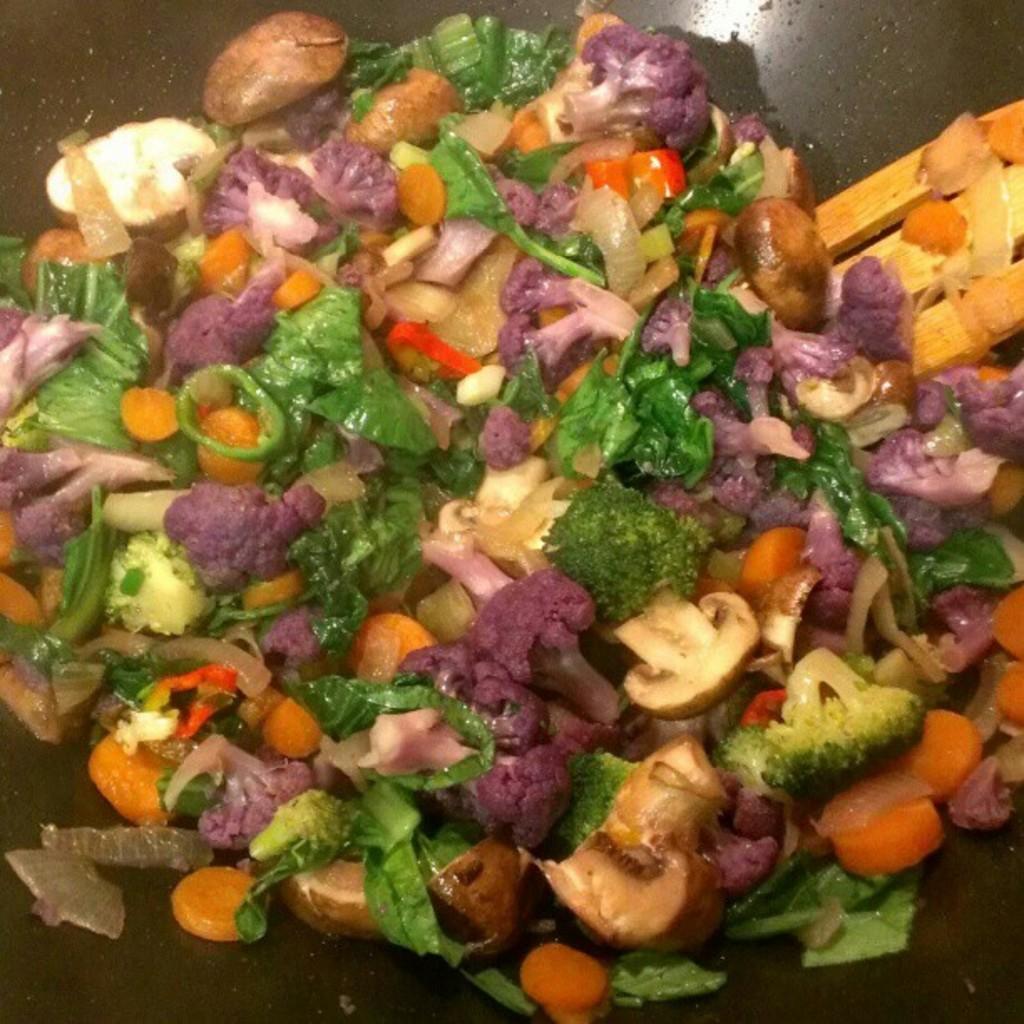How would you summarize this image in a sentence or two? In this pure, it looks like a black pan and on the pan there are some food items and a wooden spatula. 